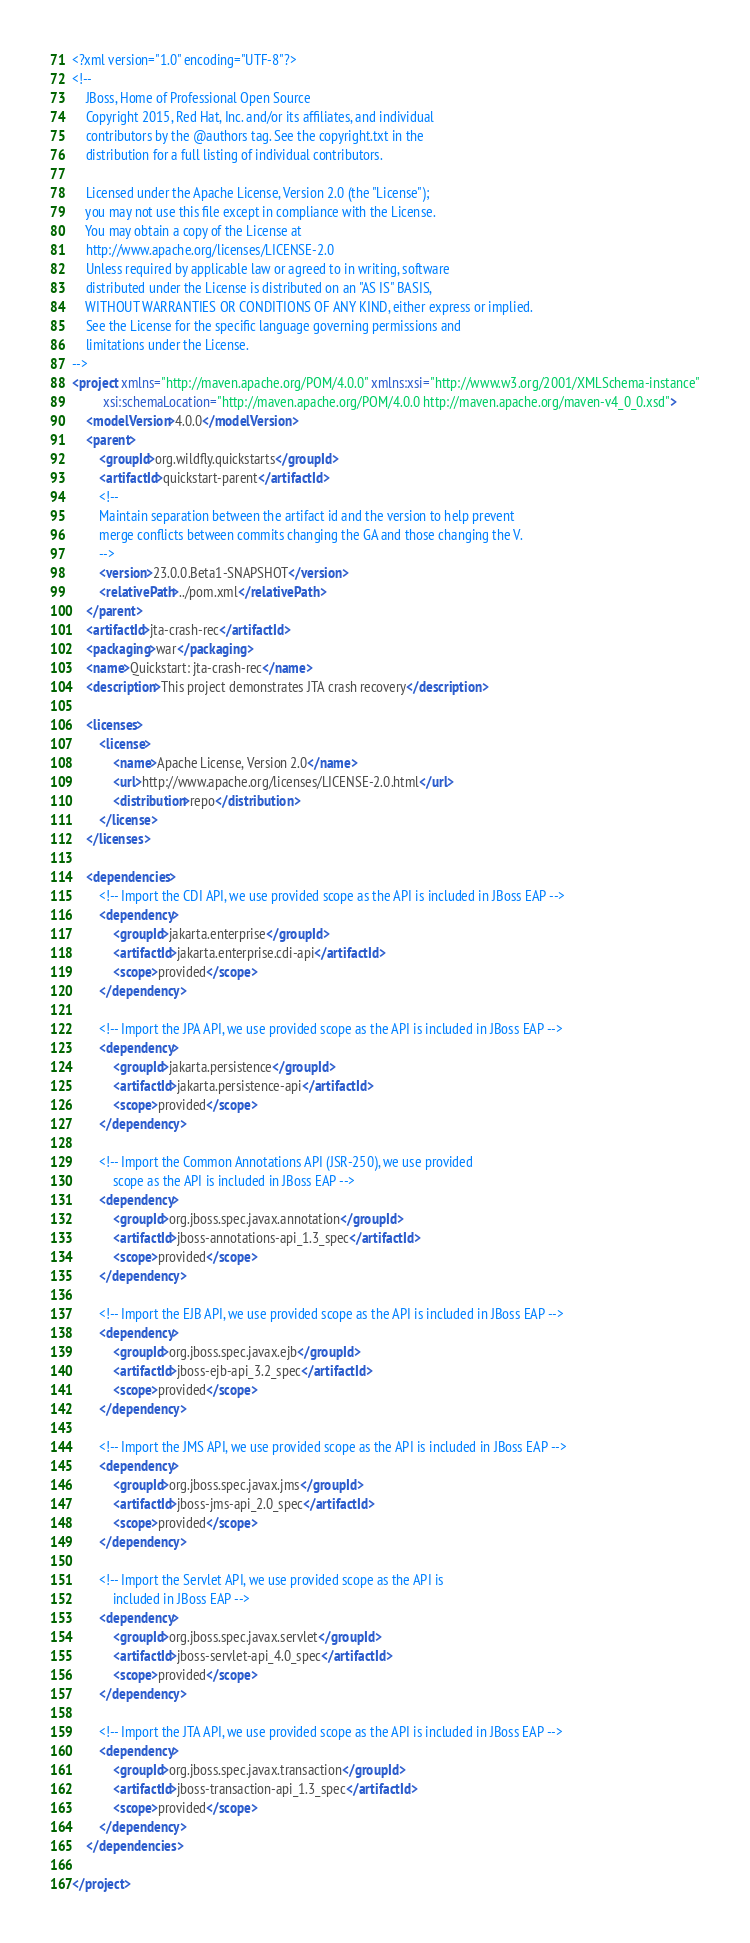<code> <loc_0><loc_0><loc_500><loc_500><_XML_><?xml version="1.0" encoding="UTF-8"?>
<!--
    JBoss, Home of Professional Open Source
    Copyright 2015, Red Hat, Inc. and/or its affiliates, and individual
    contributors by the @authors tag. See the copyright.txt in the
    distribution for a full listing of individual contributors.

    Licensed under the Apache License, Version 2.0 (the "License");
    you may not use this file except in compliance with the License.
    You may obtain a copy of the License at
    http://www.apache.org/licenses/LICENSE-2.0
    Unless required by applicable law or agreed to in writing, software
    distributed under the License is distributed on an "AS IS" BASIS,
    WITHOUT WARRANTIES OR CONDITIONS OF ANY KIND, either express or implied.
    See the License for the specific language governing permissions and
    limitations under the License.
-->
<project xmlns="http://maven.apache.org/POM/4.0.0" xmlns:xsi="http://www.w3.org/2001/XMLSchema-instance"
         xsi:schemaLocation="http://maven.apache.org/POM/4.0.0 http://maven.apache.org/maven-v4_0_0.xsd">
    <modelVersion>4.0.0</modelVersion>
    <parent>
        <groupId>org.wildfly.quickstarts</groupId>
        <artifactId>quickstart-parent</artifactId>
        <!--
        Maintain separation between the artifact id and the version to help prevent
        merge conflicts between commits changing the GA and those changing the V.
        -->
        <version>23.0.0.Beta1-SNAPSHOT</version>
        <relativePath>../pom.xml</relativePath>
    </parent>
    <artifactId>jta-crash-rec</artifactId>
    <packaging>war</packaging>
    <name>Quickstart: jta-crash-rec</name>
    <description>This project demonstrates JTA crash recovery</description>

    <licenses>
        <license>
            <name>Apache License, Version 2.0</name>
            <url>http://www.apache.org/licenses/LICENSE-2.0.html</url>
            <distribution>repo</distribution>
        </license>
    </licenses>

    <dependencies>
        <!-- Import the CDI API, we use provided scope as the API is included in JBoss EAP -->
        <dependency>
            <groupId>jakarta.enterprise</groupId>
            <artifactId>jakarta.enterprise.cdi-api</artifactId>
            <scope>provided</scope>
        </dependency>

        <!-- Import the JPA API, we use provided scope as the API is included in JBoss EAP -->
        <dependency>
            <groupId>jakarta.persistence</groupId>
            <artifactId>jakarta.persistence-api</artifactId>
            <scope>provided</scope>
        </dependency>

        <!-- Import the Common Annotations API (JSR-250), we use provided
            scope as the API is included in JBoss EAP -->
        <dependency>
            <groupId>org.jboss.spec.javax.annotation</groupId>
            <artifactId>jboss-annotations-api_1.3_spec</artifactId>
            <scope>provided</scope>
        </dependency>

        <!-- Import the EJB API, we use provided scope as the API is included in JBoss EAP -->
        <dependency>
            <groupId>org.jboss.spec.javax.ejb</groupId>
            <artifactId>jboss-ejb-api_3.2_spec</artifactId>
            <scope>provided</scope>
        </dependency>

        <!-- Import the JMS API, we use provided scope as the API is included in JBoss EAP -->
        <dependency>
            <groupId>org.jboss.spec.javax.jms</groupId>
            <artifactId>jboss-jms-api_2.0_spec</artifactId>
            <scope>provided</scope>
        </dependency>

        <!-- Import the Servlet API, we use provided scope as the API is
            included in JBoss EAP -->
        <dependency>
            <groupId>org.jboss.spec.javax.servlet</groupId>
            <artifactId>jboss-servlet-api_4.0_spec</artifactId>
            <scope>provided</scope>
        </dependency>

        <!-- Import the JTA API, we use provided scope as the API is included in JBoss EAP -->
        <dependency>
            <groupId>org.jboss.spec.javax.transaction</groupId>
            <artifactId>jboss-transaction-api_1.3_spec</artifactId>
            <scope>provided</scope>
        </dependency>
    </dependencies>
    
</project>
</code> 